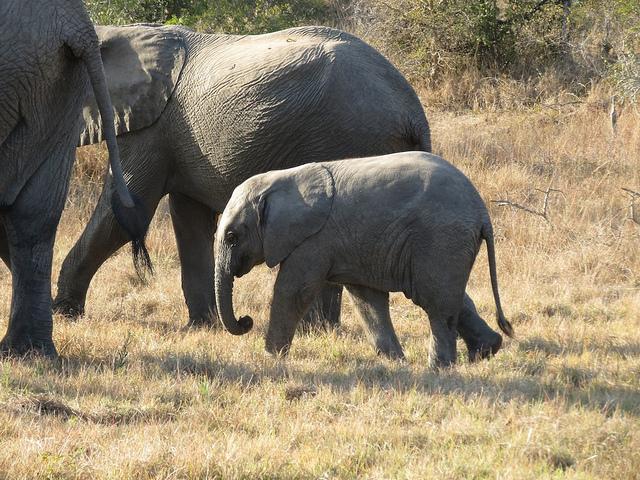What is the baby elephant reaching for?
Be succinct. Food. Is there a giraffe here?
Write a very short answer. No. Where are these elephants going?
Quick response, please. To left. Is the elephant happy?
Write a very short answer. Yes. 